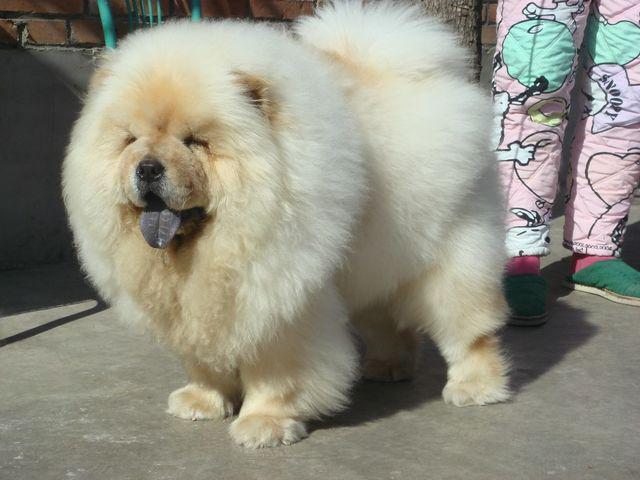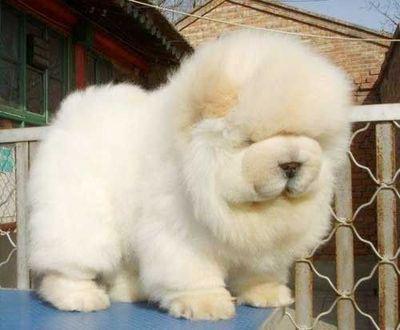The first image is the image on the left, the second image is the image on the right. Given the left and right images, does the statement "A chow with orange-tinged fur is posed on a greenish surface in at least one image." hold true? Answer yes or no. No. The first image is the image on the left, the second image is the image on the right. For the images shown, is this caption "The dogs are standing outside, but not on the grass." true? Answer yes or no. Yes. 